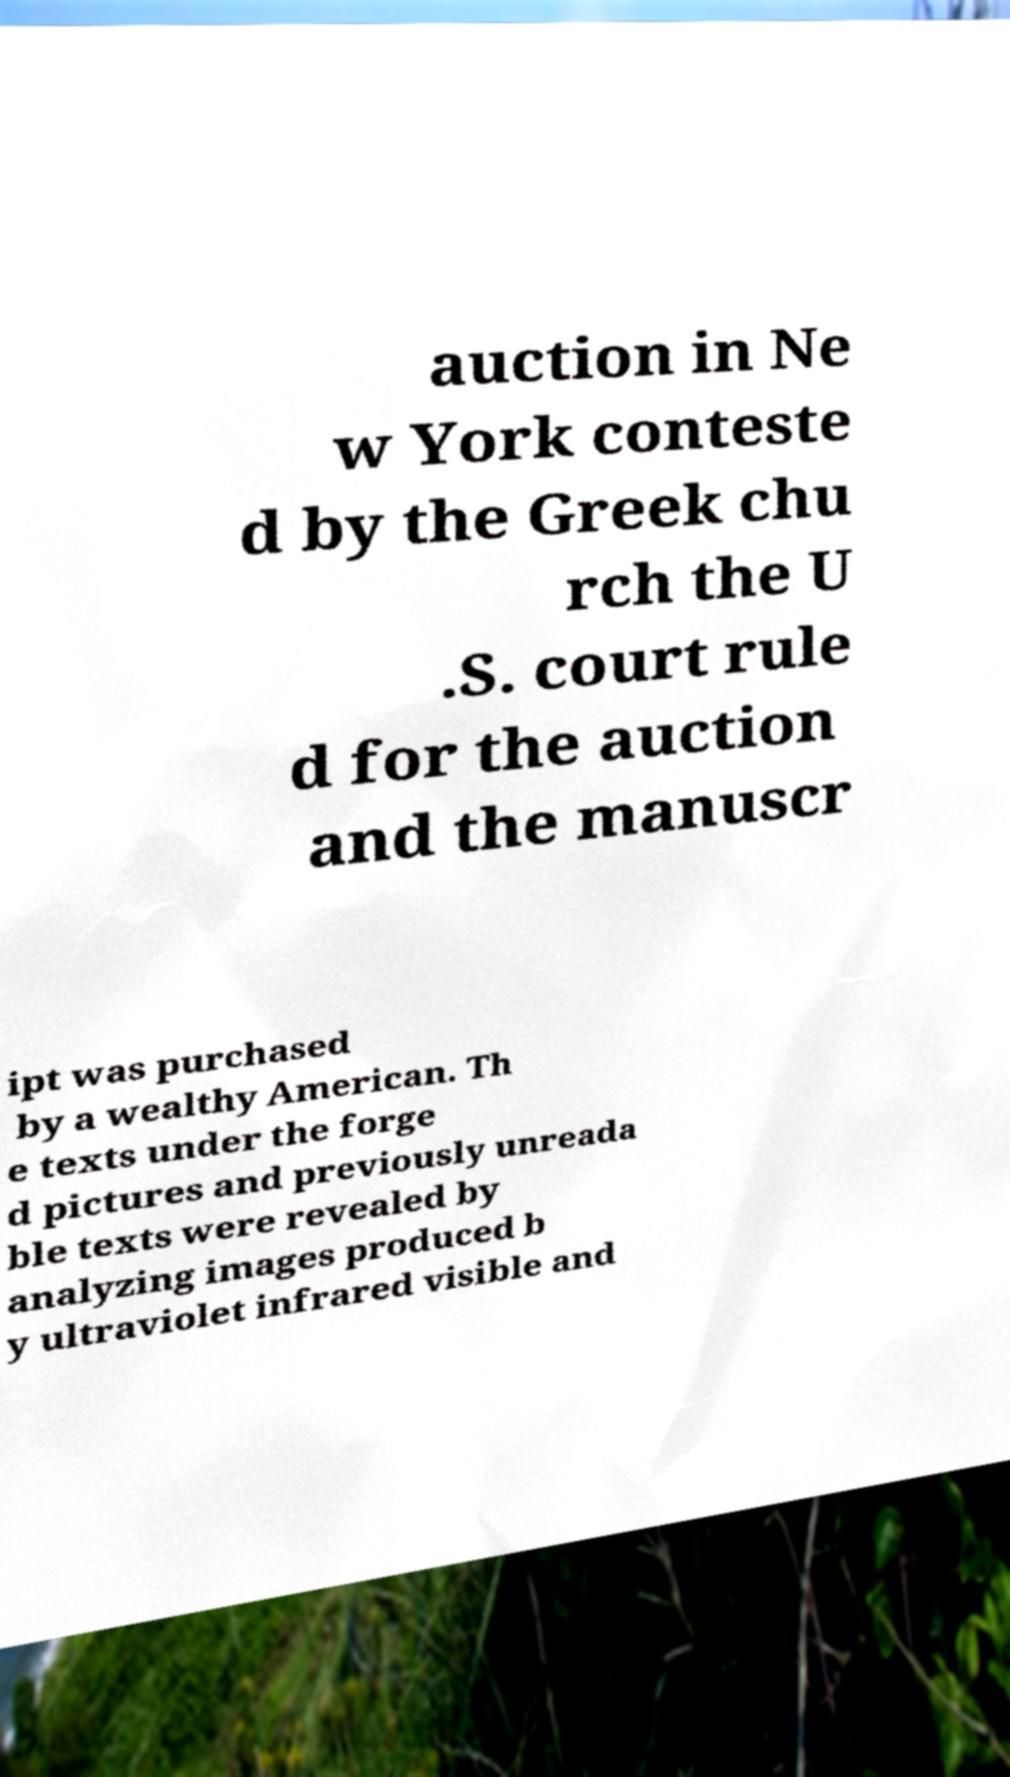I need the written content from this picture converted into text. Can you do that? auction in Ne w York conteste d by the Greek chu rch the U .S. court rule d for the auction and the manuscr ipt was purchased by a wealthy American. Th e texts under the forge d pictures and previously unreada ble texts were revealed by analyzing images produced b y ultraviolet infrared visible and 